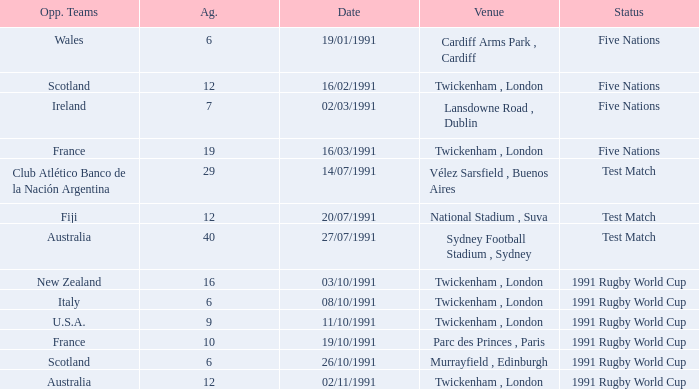What is Against, when Opposing Teams is "Australia", and when Date is "27/07/1991"? 40.0. 